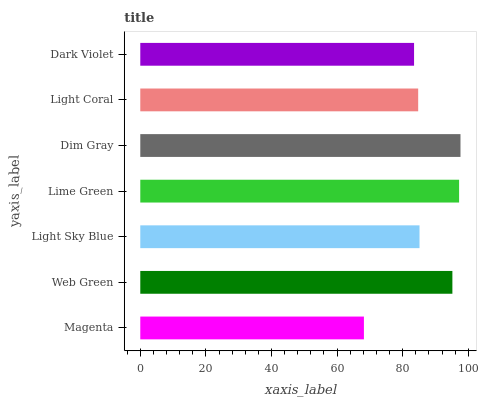Is Magenta the minimum?
Answer yes or no. Yes. Is Dim Gray the maximum?
Answer yes or no. Yes. Is Web Green the minimum?
Answer yes or no. No. Is Web Green the maximum?
Answer yes or no. No. Is Web Green greater than Magenta?
Answer yes or no. Yes. Is Magenta less than Web Green?
Answer yes or no. Yes. Is Magenta greater than Web Green?
Answer yes or no. No. Is Web Green less than Magenta?
Answer yes or no. No. Is Light Sky Blue the high median?
Answer yes or no. Yes. Is Light Sky Blue the low median?
Answer yes or no. Yes. Is Dim Gray the high median?
Answer yes or no. No. Is Web Green the low median?
Answer yes or no. No. 